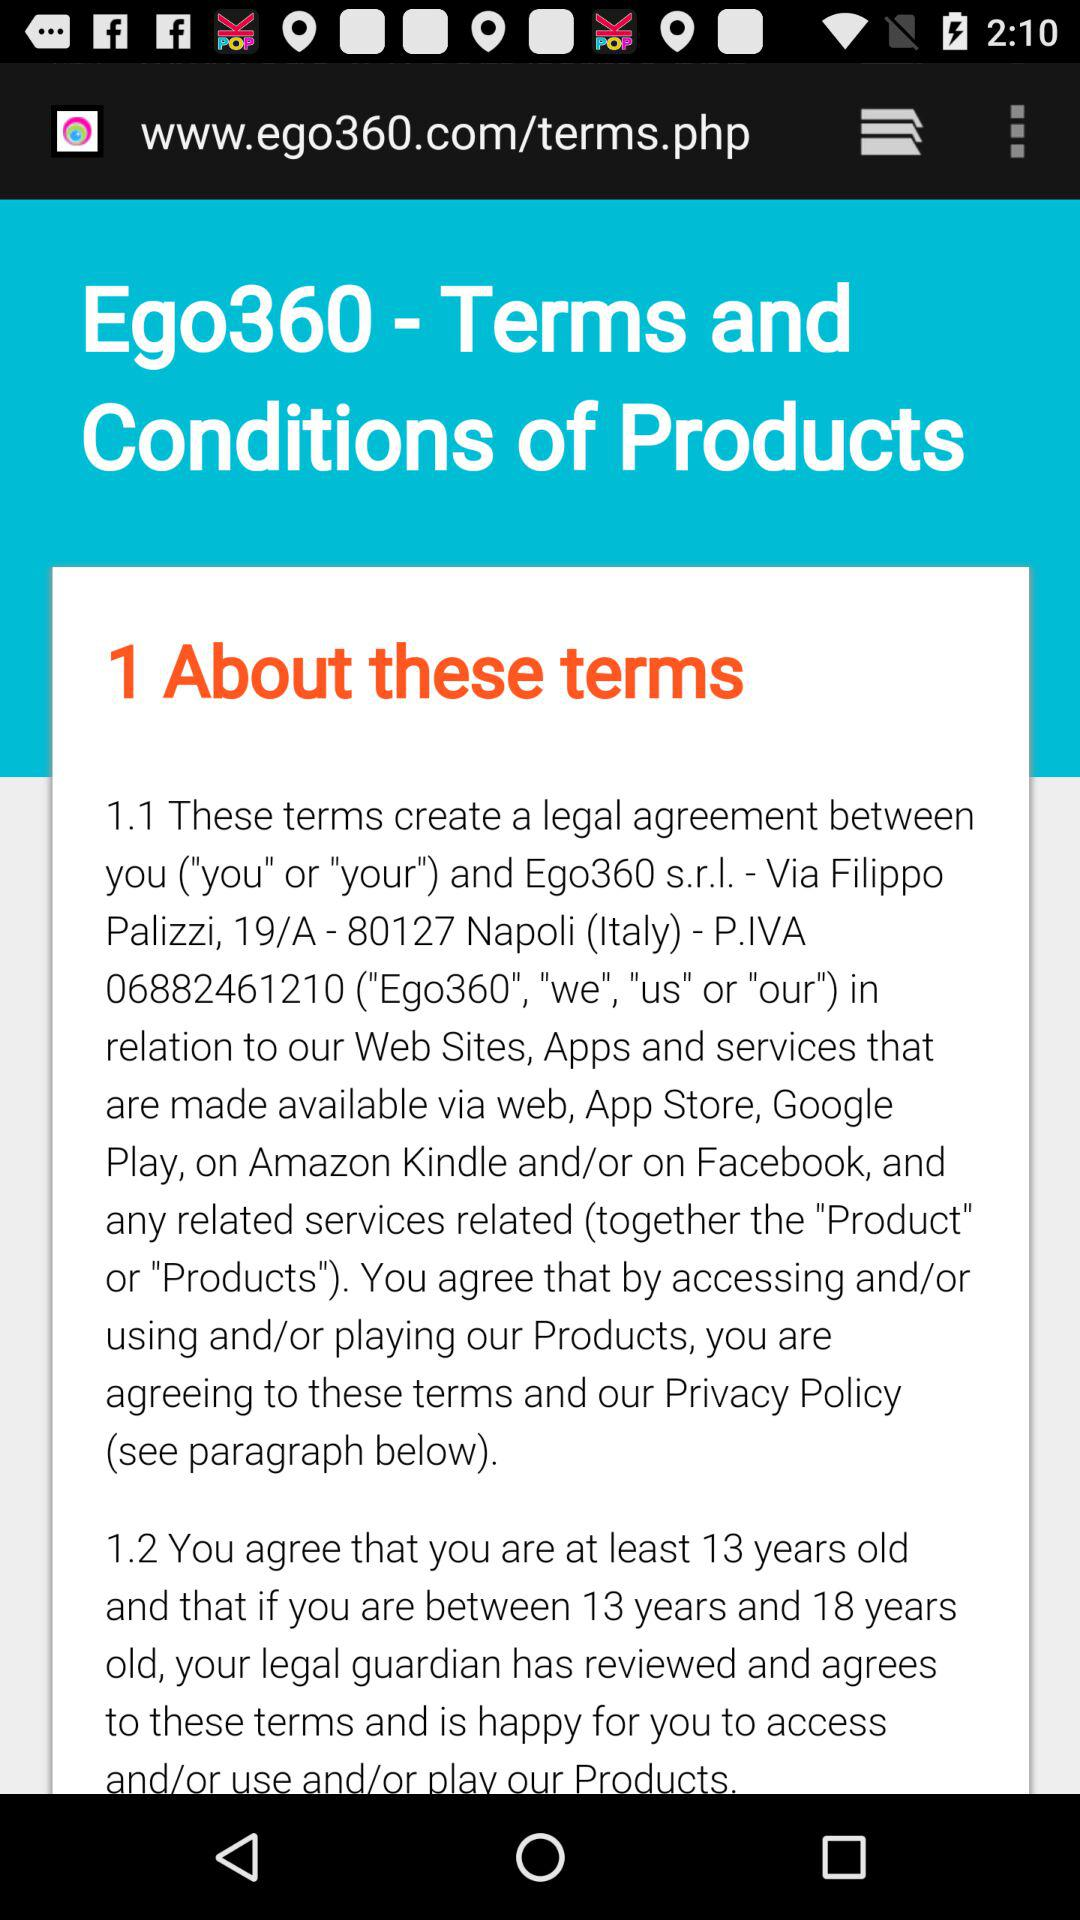What is the name of the application?
When the provided information is insufficient, respond with <no answer>. <no answer> 